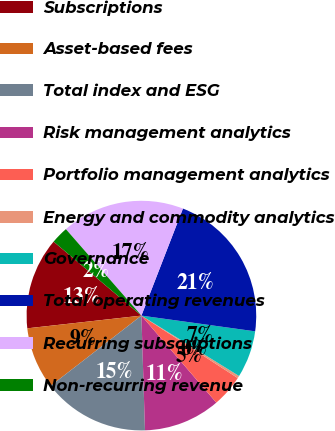Convert chart to OTSL. <chart><loc_0><loc_0><loc_500><loc_500><pie_chart><fcel>Subscriptions<fcel>Asset-based fees<fcel>Total index and ESG<fcel>Risk management analytics<fcel>Portfolio management analytics<fcel>Energy and commodity analytics<fcel>Governance<fcel>Total operating revenues<fcel>Recurring subscriptions<fcel>Non-recurring revenue<nl><fcel>12.91%<fcel>8.72%<fcel>15.01%<fcel>10.82%<fcel>4.53%<fcel>0.34%<fcel>6.63%<fcel>21.3%<fcel>17.32%<fcel>2.43%<nl></chart> 